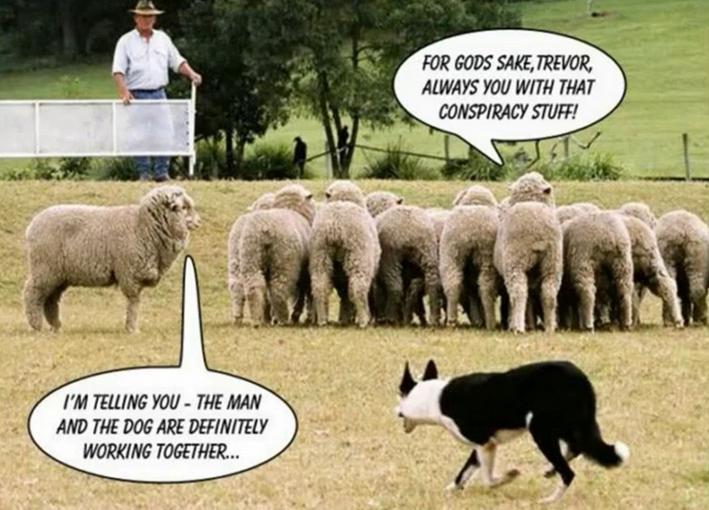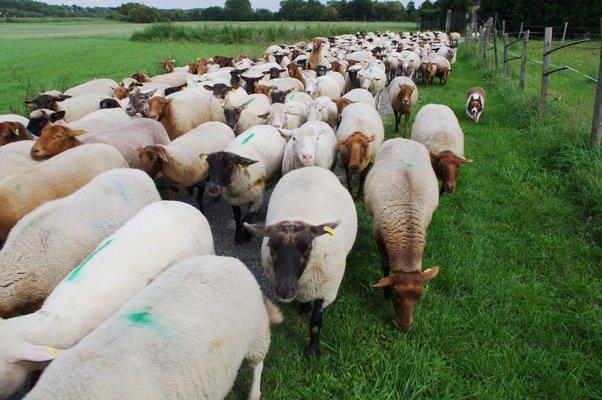The first image is the image on the left, the second image is the image on the right. For the images displayed, is the sentence "A person is standing with the dog and sheep in one of the images." factually correct? Answer yes or no. Yes. 